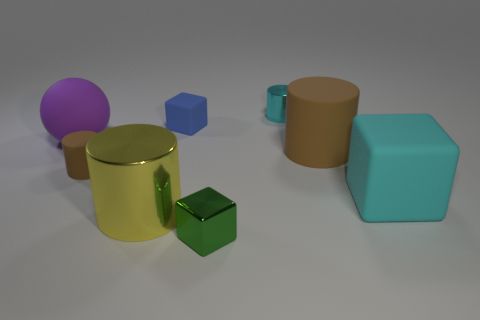How many other objects are there of the same size as the purple ball?
Your answer should be very brief. 3. Do the cyan thing that is to the right of the small cyan cylinder and the small green thing have the same shape?
Offer a very short reply. Yes. Are there more large brown things in front of the tiny blue thing than small green matte blocks?
Your answer should be very brief. Yes. What is the material of the big object that is in front of the purple ball and behind the large rubber cube?
Make the answer very short. Rubber. Is there anything else that is the same shape as the purple matte thing?
Provide a short and direct response. No. What number of objects are to the left of the small green shiny thing and right of the tiny cyan metallic object?
Make the answer very short. 0. What is the material of the tiny blue thing?
Your response must be concise. Rubber. Are there the same number of large cyan blocks on the left side of the small brown object and purple cylinders?
Make the answer very short. Yes. What number of small green objects have the same shape as the large purple object?
Provide a short and direct response. 0. Is the shape of the small brown rubber object the same as the blue rubber object?
Your answer should be very brief. No. 